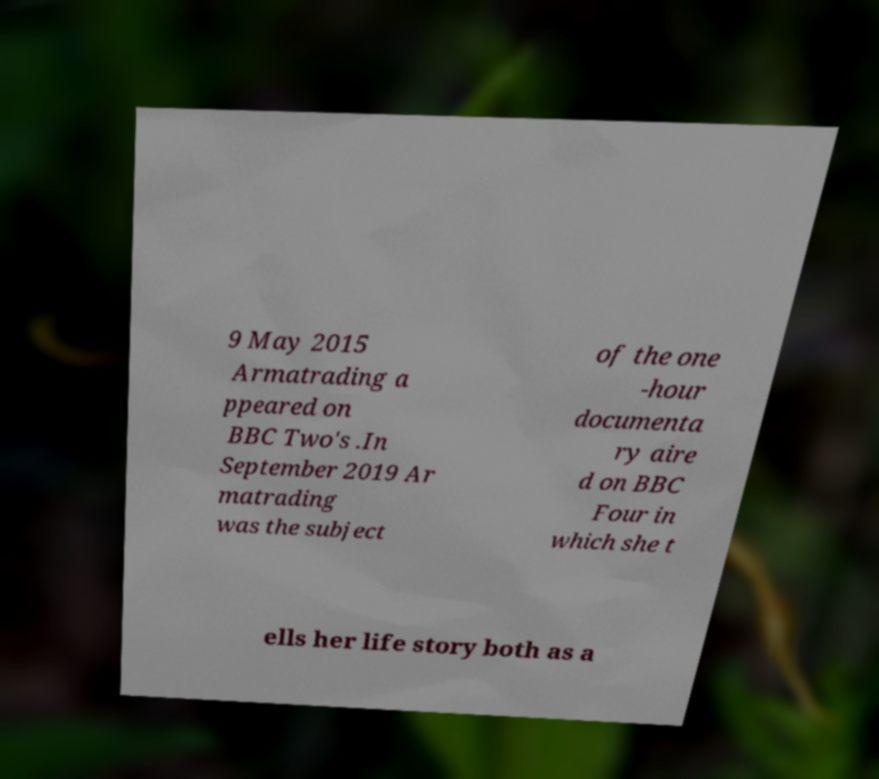Please read and relay the text visible in this image. What does it say? 9 May 2015 Armatrading a ppeared on BBC Two's .In September 2019 Ar matrading was the subject of the one -hour documenta ry aire d on BBC Four in which she t ells her life story both as a 